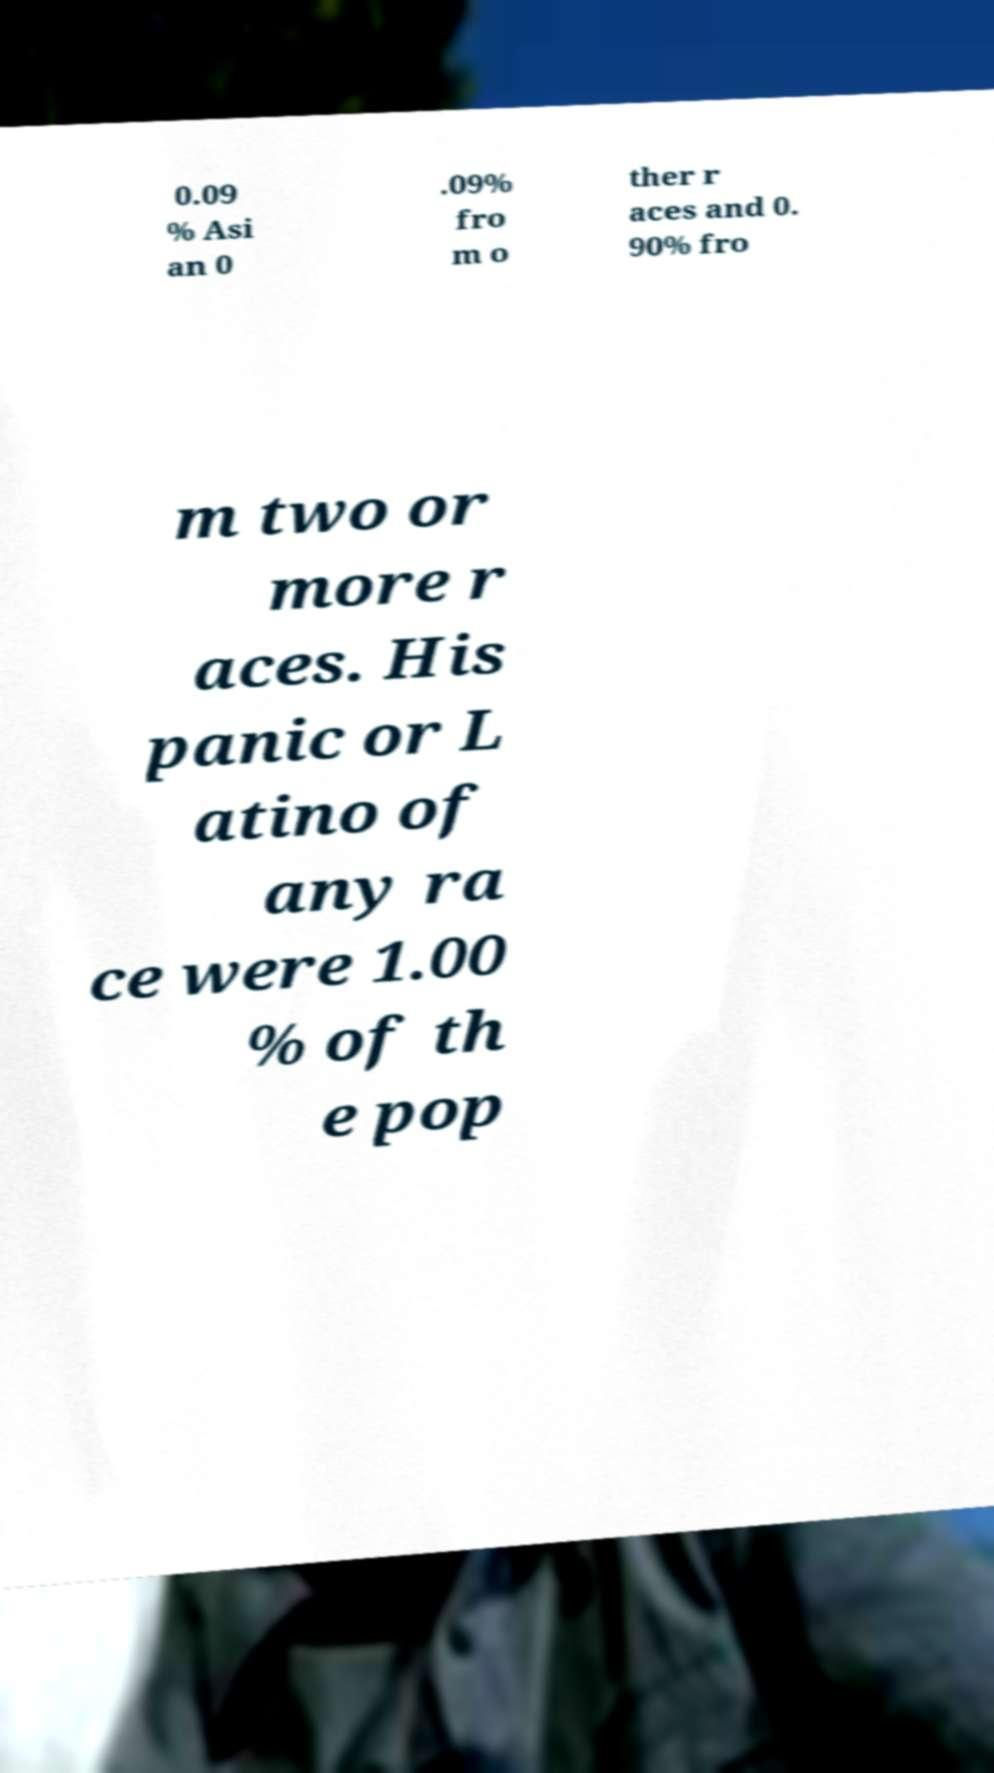I need the written content from this picture converted into text. Can you do that? 0.09 % Asi an 0 .09% fro m o ther r aces and 0. 90% fro m two or more r aces. His panic or L atino of any ra ce were 1.00 % of th e pop 